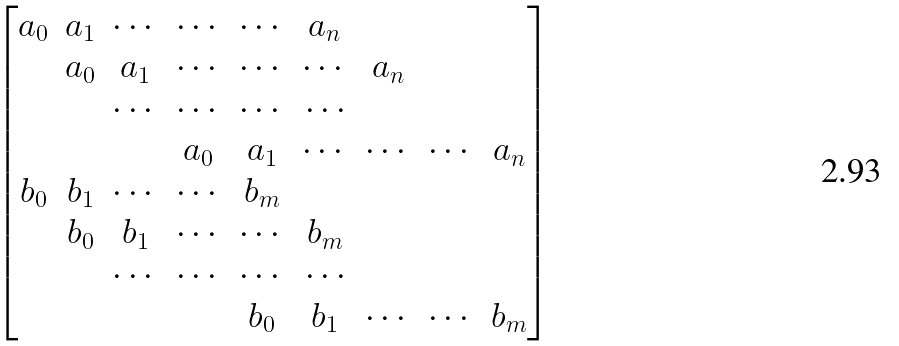<formula> <loc_0><loc_0><loc_500><loc_500>\begin{bmatrix} a _ { 0 } & a _ { 1 } & \cdots & \cdots & \cdots & a _ { n } \\ & a _ { 0 } & a _ { 1 } & \cdots & \cdots & \cdots & a _ { n } \\ & & \cdots & \cdots & \cdots & \cdots \\ & & & a _ { 0 } & a _ { 1 } & \cdots & \cdots & \cdots & a _ { n } \\ b _ { 0 } & b _ { 1 } & \cdots & \cdots & b _ { m } \\ & b _ { 0 } & b _ { 1 } & \cdots & \cdots & b _ { m } \\ & & \cdots & \cdots & \cdots & \cdots \\ & & & & b _ { 0 } & b _ { 1 } & \cdots & \cdots & b _ { m } \end{bmatrix}</formula> 